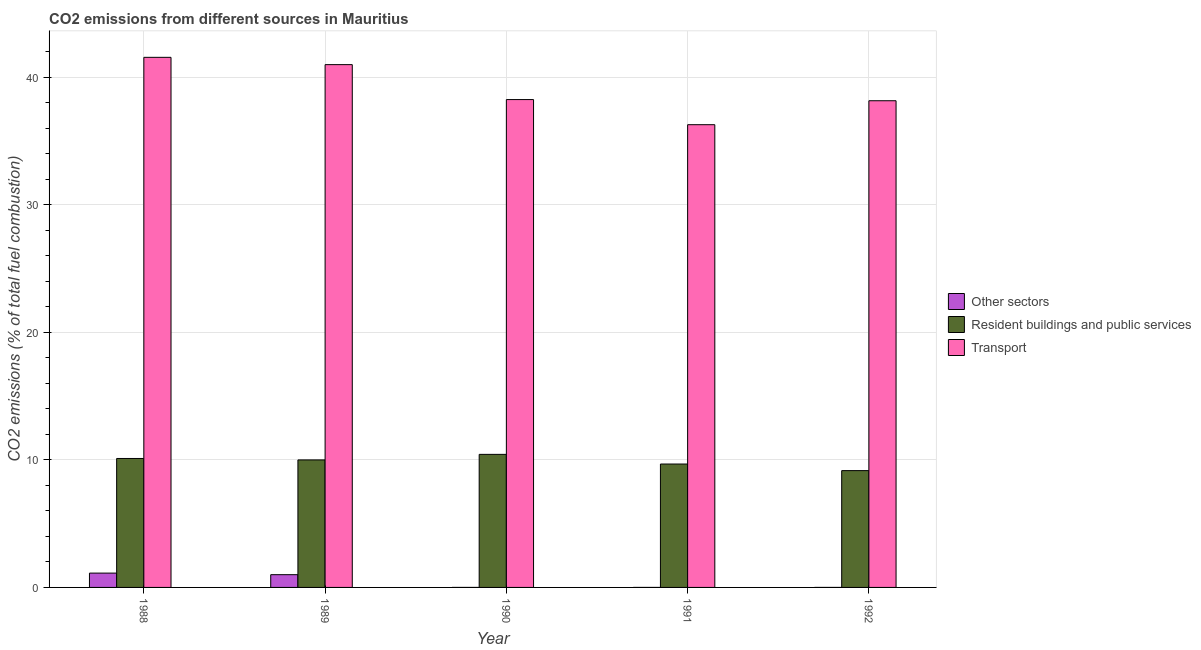Are the number of bars per tick equal to the number of legend labels?
Provide a short and direct response. No. How many bars are there on the 5th tick from the left?
Give a very brief answer. 2. How many bars are there on the 2nd tick from the right?
Offer a terse response. 2. What is the label of the 3rd group of bars from the left?
Your response must be concise. 1990. What is the percentage of co2 emissions from transport in 1992?
Your response must be concise. 38.17. Across all years, what is the maximum percentage of co2 emissions from resident buildings and public services?
Provide a short and direct response. 10.43. Across all years, what is the minimum percentage of co2 emissions from resident buildings and public services?
Ensure brevity in your answer.  9.16. What is the total percentage of co2 emissions from resident buildings and public services in the graph?
Your answer should be very brief. 49.38. What is the difference between the percentage of co2 emissions from resident buildings and public services in 1988 and that in 1990?
Keep it short and to the point. -0.32. What is the difference between the percentage of co2 emissions from resident buildings and public services in 1989 and the percentage of co2 emissions from other sectors in 1988?
Your answer should be very brief. -0.11. What is the average percentage of co2 emissions from resident buildings and public services per year?
Offer a very short reply. 9.88. In the year 1991, what is the difference between the percentage of co2 emissions from resident buildings and public services and percentage of co2 emissions from transport?
Ensure brevity in your answer.  0. In how many years, is the percentage of co2 emissions from resident buildings and public services greater than 6 %?
Make the answer very short. 5. What is the ratio of the percentage of co2 emissions from transport in 1989 to that in 1990?
Your response must be concise. 1.07. Is the percentage of co2 emissions from transport in 1989 less than that in 1992?
Ensure brevity in your answer.  No. Is the difference between the percentage of co2 emissions from resident buildings and public services in 1988 and 1990 greater than the difference between the percentage of co2 emissions from transport in 1988 and 1990?
Make the answer very short. No. What is the difference between the highest and the second highest percentage of co2 emissions from transport?
Give a very brief answer. 0.57. What is the difference between the highest and the lowest percentage of co2 emissions from transport?
Offer a very short reply. 5.28. In how many years, is the percentage of co2 emissions from transport greater than the average percentage of co2 emissions from transport taken over all years?
Your response must be concise. 2. Is it the case that in every year, the sum of the percentage of co2 emissions from other sectors and percentage of co2 emissions from resident buildings and public services is greater than the percentage of co2 emissions from transport?
Ensure brevity in your answer.  No. How many bars are there?
Provide a short and direct response. 12. Are all the bars in the graph horizontal?
Your response must be concise. No. Are the values on the major ticks of Y-axis written in scientific E-notation?
Your response must be concise. No. Does the graph contain any zero values?
Your answer should be compact. Yes. What is the title of the graph?
Your answer should be compact. CO2 emissions from different sources in Mauritius. What is the label or title of the Y-axis?
Provide a short and direct response. CO2 emissions (% of total fuel combustion). What is the CO2 emissions (% of total fuel combustion) of Other sectors in 1988?
Keep it short and to the point. 1.12. What is the CO2 emissions (% of total fuel combustion) in Resident buildings and public services in 1988?
Offer a terse response. 10.11. What is the CO2 emissions (% of total fuel combustion) of Transport in 1988?
Provide a succinct answer. 41.57. What is the CO2 emissions (% of total fuel combustion) of Other sectors in 1989?
Provide a short and direct response. 1. What is the CO2 emissions (% of total fuel combustion) of Resident buildings and public services in 1990?
Provide a short and direct response. 10.43. What is the CO2 emissions (% of total fuel combustion) in Transport in 1990?
Give a very brief answer. 38.26. What is the CO2 emissions (% of total fuel combustion) in Other sectors in 1991?
Your response must be concise. 0. What is the CO2 emissions (% of total fuel combustion) of Resident buildings and public services in 1991?
Provide a short and direct response. 9.68. What is the CO2 emissions (% of total fuel combustion) of Transport in 1991?
Provide a succinct answer. 36.29. What is the CO2 emissions (% of total fuel combustion) in Resident buildings and public services in 1992?
Provide a short and direct response. 9.16. What is the CO2 emissions (% of total fuel combustion) of Transport in 1992?
Your response must be concise. 38.17. Across all years, what is the maximum CO2 emissions (% of total fuel combustion) in Other sectors?
Provide a succinct answer. 1.12. Across all years, what is the maximum CO2 emissions (% of total fuel combustion) of Resident buildings and public services?
Provide a succinct answer. 10.43. Across all years, what is the maximum CO2 emissions (% of total fuel combustion) in Transport?
Your response must be concise. 41.57. Across all years, what is the minimum CO2 emissions (% of total fuel combustion) of Other sectors?
Keep it short and to the point. 0. Across all years, what is the minimum CO2 emissions (% of total fuel combustion) of Resident buildings and public services?
Your response must be concise. 9.16. Across all years, what is the minimum CO2 emissions (% of total fuel combustion) in Transport?
Make the answer very short. 36.29. What is the total CO2 emissions (% of total fuel combustion) in Other sectors in the graph?
Your answer should be compact. 2.12. What is the total CO2 emissions (% of total fuel combustion) in Resident buildings and public services in the graph?
Your answer should be compact. 49.38. What is the total CO2 emissions (% of total fuel combustion) of Transport in the graph?
Give a very brief answer. 195.29. What is the difference between the CO2 emissions (% of total fuel combustion) in Other sectors in 1988 and that in 1989?
Your answer should be very brief. 0.12. What is the difference between the CO2 emissions (% of total fuel combustion) of Resident buildings and public services in 1988 and that in 1989?
Your response must be concise. 0.11. What is the difference between the CO2 emissions (% of total fuel combustion) in Transport in 1988 and that in 1989?
Offer a very short reply. 0.57. What is the difference between the CO2 emissions (% of total fuel combustion) in Resident buildings and public services in 1988 and that in 1990?
Keep it short and to the point. -0.32. What is the difference between the CO2 emissions (% of total fuel combustion) of Transport in 1988 and that in 1990?
Offer a terse response. 3.31. What is the difference between the CO2 emissions (% of total fuel combustion) of Resident buildings and public services in 1988 and that in 1991?
Ensure brevity in your answer.  0.43. What is the difference between the CO2 emissions (% of total fuel combustion) in Transport in 1988 and that in 1991?
Provide a succinct answer. 5.28. What is the difference between the CO2 emissions (% of total fuel combustion) in Resident buildings and public services in 1988 and that in 1992?
Your answer should be compact. 0.95. What is the difference between the CO2 emissions (% of total fuel combustion) of Transport in 1988 and that in 1992?
Ensure brevity in your answer.  3.41. What is the difference between the CO2 emissions (% of total fuel combustion) of Resident buildings and public services in 1989 and that in 1990?
Offer a very short reply. -0.43. What is the difference between the CO2 emissions (% of total fuel combustion) in Transport in 1989 and that in 1990?
Your answer should be very brief. 2.74. What is the difference between the CO2 emissions (% of total fuel combustion) in Resident buildings and public services in 1989 and that in 1991?
Offer a very short reply. 0.32. What is the difference between the CO2 emissions (% of total fuel combustion) in Transport in 1989 and that in 1991?
Provide a succinct answer. 4.71. What is the difference between the CO2 emissions (% of total fuel combustion) in Resident buildings and public services in 1989 and that in 1992?
Offer a terse response. 0.84. What is the difference between the CO2 emissions (% of total fuel combustion) of Transport in 1989 and that in 1992?
Provide a short and direct response. 2.83. What is the difference between the CO2 emissions (% of total fuel combustion) in Resident buildings and public services in 1990 and that in 1991?
Provide a succinct answer. 0.76. What is the difference between the CO2 emissions (% of total fuel combustion) of Transport in 1990 and that in 1991?
Provide a short and direct response. 1.97. What is the difference between the CO2 emissions (% of total fuel combustion) in Resident buildings and public services in 1990 and that in 1992?
Make the answer very short. 1.27. What is the difference between the CO2 emissions (% of total fuel combustion) of Transport in 1990 and that in 1992?
Provide a short and direct response. 0.09. What is the difference between the CO2 emissions (% of total fuel combustion) of Resident buildings and public services in 1991 and that in 1992?
Ensure brevity in your answer.  0.52. What is the difference between the CO2 emissions (% of total fuel combustion) of Transport in 1991 and that in 1992?
Your answer should be very brief. -1.88. What is the difference between the CO2 emissions (% of total fuel combustion) of Other sectors in 1988 and the CO2 emissions (% of total fuel combustion) of Resident buildings and public services in 1989?
Your response must be concise. -8.88. What is the difference between the CO2 emissions (% of total fuel combustion) in Other sectors in 1988 and the CO2 emissions (% of total fuel combustion) in Transport in 1989?
Keep it short and to the point. -39.88. What is the difference between the CO2 emissions (% of total fuel combustion) in Resident buildings and public services in 1988 and the CO2 emissions (% of total fuel combustion) in Transport in 1989?
Your answer should be compact. -30.89. What is the difference between the CO2 emissions (% of total fuel combustion) in Other sectors in 1988 and the CO2 emissions (% of total fuel combustion) in Resident buildings and public services in 1990?
Provide a succinct answer. -9.31. What is the difference between the CO2 emissions (% of total fuel combustion) in Other sectors in 1988 and the CO2 emissions (% of total fuel combustion) in Transport in 1990?
Provide a short and direct response. -37.14. What is the difference between the CO2 emissions (% of total fuel combustion) of Resident buildings and public services in 1988 and the CO2 emissions (% of total fuel combustion) of Transport in 1990?
Offer a very short reply. -28.15. What is the difference between the CO2 emissions (% of total fuel combustion) in Other sectors in 1988 and the CO2 emissions (% of total fuel combustion) in Resident buildings and public services in 1991?
Keep it short and to the point. -8.55. What is the difference between the CO2 emissions (% of total fuel combustion) in Other sectors in 1988 and the CO2 emissions (% of total fuel combustion) in Transport in 1991?
Provide a short and direct response. -35.17. What is the difference between the CO2 emissions (% of total fuel combustion) in Resident buildings and public services in 1988 and the CO2 emissions (% of total fuel combustion) in Transport in 1991?
Provide a short and direct response. -26.18. What is the difference between the CO2 emissions (% of total fuel combustion) in Other sectors in 1988 and the CO2 emissions (% of total fuel combustion) in Resident buildings and public services in 1992?
Offer a very short reply. -8.04. What is the difference between the CO2 emissions (% of total fuel combustion) of Other sectors in 1988 and the CO2 emissions (% of total fuel combustion) of Transport in 1992?
Your answer should be very brief. -37.04. What is the difference between the CO2 emissions (% of total fuel combustion) of Resident buildings and public services in 1988 and the CO2 emissions (% of total fuel combustion) of Transport in 1992?
Keep it short and to the point. -28.06. What is the difference between the CO2 emissions (% of total fuel combustion) of Other sectors in 1989 and the CO2 emissions (% of total fuel combustion) of Resident buildings and public services in 1990?
Make the answer very short. -9.43. What is the difference between the CO2 emissions (% of total fuel combustion) in Other sectors in 1989 and the CO2 emissions (% of total fuel combustion) in Transport in 1990?
Make the answer very short. -37.26. What is the difference between the CO2 emissions (% of total fuel combustion) in Resident buildings and public services in 1989 and the CO2 emissions (% of total fuel combustion) in Transport in 1990?
Ensure brevity in your answer.  -28.26. What is the difference between the CO2 emissions (% of total fuel combustion) in Other sectors in 1989 and the CO2 emissions (% of total fuel combustion) in Resident buildings and public services in 1991?
Your response must be concise. -8.68. What is the difference between the CO2 emissions (% of total fuel combustion) of Other sectors in 1989 and the CO2 emissions (% of total fuel combustion) of Transport in 1991?
Give a very brief answer. -35.29. What is the difference between the CO2 emissions (% of total fuel combustion) of Resident buildings and public services in 1989 and the CO2 emissions (% of total fuel combustion) of Transport in 1991?
Make the answer very short. -26.29. What is the difference between the CO2 emissions (% of total fuel combustion) of Other sectors in 1989 and the CO2 emissions (% of total fuel combustion) of Resident buildings and public services in 1992?
Offer a terse response. -8.16. What is the difference between the CO2 emissions (% of total fuel combustion) of Other sectors in 1989 and the CO2 emissions (% of total fuel combustion) of Transport in 1992?
Your answer should be very brief. -37.17. What is the difference between the CO2 emissions (% of total fuel combustion) in Resident buildings and public services in 1989 and the CO2 emissions (% of total fuel combustion) in Transport in 1992?
Ensure brevity in your answer.  -28.17. What is the difference between the CO2 emissions (% of total fuel combustion) of Resident buildings and public services in 1990 and the CO2 emissions (% of total fuel combustion) of Transport in 1991?
Give a very brief answer. -25.86. What is the difference between the CO2 emissions (% of total fuel combustion) of Resident buildings and public services in 1990 and the CO2 emissions (% of total fuel combustion) of Transport in 1992?
Offer a terse response. -27.73. What is the difference between the CO2 emissions (% of total fuel combustion) in Resident buildings and public services in 1991 and the CO2 emissions (% of total fuel combustion) in Transport in 1992?
Provide a short and direct response. -28.49. What is the average CO2 emissions (% of total fuel combustion) of Other sectors per year?
Provide a short and direct response. 0.42. What is the average CO2 emissions (% of total fuel combustion) of Resident buildings and public services per year?
Give a very brief answer. 9.88. What is the average CO2 emissions (% of total fuel combustion) in Transport per year?
Give a very brief answer. 39.06. In the year 1988, what is the difference between the CO2 emissions (% of total fuel combustion) of Other sectors and CO2 emissions (% of total fuel combustion) of Resident buildings and public services?
Make the answer very short. -8.99. In the year 1988, what is the difference between the CO2 emissions (% of total fuel combustion) in Other sectors and CO2 emissions (% of total fuel combustion) in Transport?
Make the answer very short. -40.45. In the year 1988, what is the difference between the CO2 emissions (% of total fuel combustion) in Resident buildings and public services and CO2 emissions (% of total fuel combustion) in Transport?
Offer a terse response. -31.46. In the year 1989, what is the difference between the CO2 emissions (% of total fuel combustion) in Other sectors and CO2 emissions (% of total fuel combustion) in Resident buildings and public services?
Your response must be concise. -9. In the year 1989, what is the difference between the CO2 emissions (% of total fuel combustion) of Other sectors and CO2 emissions (% of total fuel combustion) of Transport?
Offer a very short reply. -40. In the year 1989, what is the difference between the CO2 emissions (% of total fuel combustion) in Resident buildings and public services and CO2 emissions (% of total fuel combustion) in Transport?
Your answer should be compact. -31. In the year 1990, what is the difference between the CO2 emissions (% of total fuel combustion) of Resident buildings and public services and CO2 emissions (% of total fuel combustion) of Transport?
Provide a succinct answer. -27.83. In the year 1991, what is the difference between the CO2 emissions (% of total fuel combustion) in Resident buildings and public services and CO2 emissions (% of total fuel combustion) in Transport?
Offer a terse response. -26.61. In the year 1992, what is the difference between the CO2 emissions (% of total fuel combustion) of Resident buildings and public services and CO2 emissions (% of total fuel combustion) of Transport?
Your answer should be compact. -29.01. What is the ratio of the CO2 emissions (% of total fuel combustion) in Other sectors in 1988 to that in 1989?
Make the answer very short. 1.12. What is the ratio of the CO2 emissions (% of total fuel combustion) of Resident buildings and public services in 1988 to that in 1989?
Your answer should be very brief. 1.01. What is the ratio of the CO2 emissions (% of total fuel combustion) in Resident buildings and public services in 1988 to that in 1990?
Provide a short and direct response. 0.97. What is the ratio of the CO2 emissions (% of total fuel combustion) of Transport in 1988 to that in 1990?
Keep it short and to the point. 1.09. What is the ratio of the CO2 emissions (% of total fuel combustion) in Resident buildings and public services in 1988 to that in 1991?
Offer a very short reply. 1.04. What is the ratio of the CO2 emissions (% of total fuel combustion) of Transport in 1988 to that in 1991?
Make the answer very short. 1.15. What is the ratio of the CO2 emissions (% of total fuel combustion) of Resident buildings and public services in 1988 to that in 1992?
Make the answer very short. 1.1. What is the ratio of the CO2 emissions (% of total fuel combustion) of Transport in 1988 to that in 1992?
Make the answer very short. 1.09. What is the ratio of the CO2 emissions (% of total fuel combustion) of Transport in 1989 to that in 1990?
Offer a very short reply. 1.07. What is the ratio of the CO2 emissions (% of total fuel combustion) of Resident buildings and public services in 1989 to that in 1991?
Your response must be concise. 1.03. What is the ratio of the CO2 emissions (% of total fuel combustion) of Transport in 1989 to that in 1991?
Keep it short and to the point. 1.13. What is the ratio of the CO2 emissions (% of total fuel combustion) of Resident buildings and public services in 1989 to that in 1992?
Keep it short and to the point. 1.09. What is the ratio of the CO2 emissions (% of total fuel combustion) of Transport in 1989 to that in 1992?
Your response must be concise. 1.07. What is the ratio of the CO2 emissions (% of total fuel combustion) of Resident buildings and public services in 1990 to that in 1991?
Provide a short and direct response. 1.08. What is the ratio of the CO2 emissions (% of total fuel combustion) in Transport in 1990 to that in 1991?
Provide a succinct answer. 1.05. What is the ratio of the CO2 emissions (% of total fuel combustion) in Resident buildings and public services in 1990 to that in 1992?
Keep it short and to the point. 1.14. What is the ratio of the CO2 emissions (% of total fuel combustion) in Resident buildings and public services in 1991 to that in 1992?
Your answer should be very brief. 1.06. What is the ratio of the CO2 emissions (% of total fuel combustion) of Transport in 1991 to that in 1992?
Make the answer very short. 0.95. What is the difference between the highest and the second highest CO2 emissions (% of total fuel combustion) in Resident buildings and public services?
Give a very brief answer. 0.32. What is the difference between the highest and the second highest CO2 emissions (% of total fuel combustion) of Transport?
Your response must be concise. 0.57. What is the difference between the highest and the lowest CO2 emissions (% of total fuel combustion) in Other sectors?
Offer a very short reply. 1.12. What is the difference between the highest and the lowest CO2 emissions (% of total fuel combustion) of Resident buildings and public services?
Keep it short and to the point. 1.27. What is the difference between the highest and the lowest CO2 emissions (% of total fuel combustion) of Transport?
Ensure brevity in your answer.  5.28. 